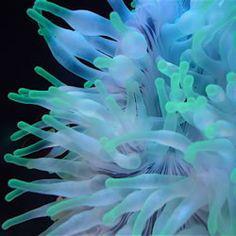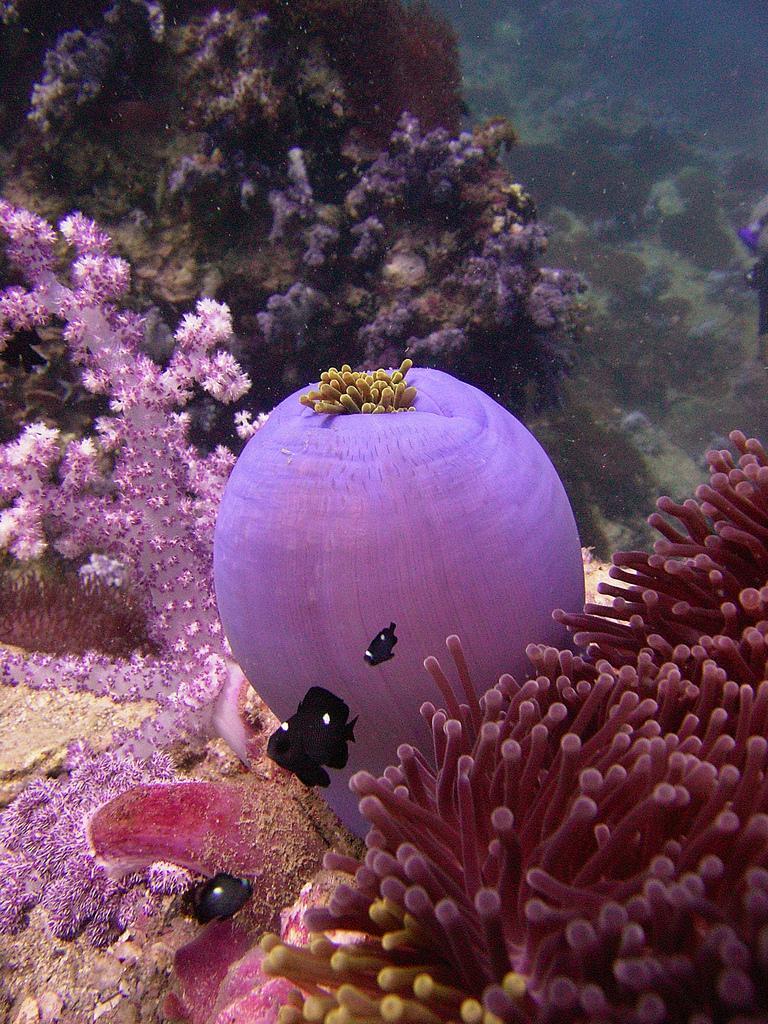The first image is the image on the left, the second image is the image on the right. For the images shown, is this caption "One of the anemones is spherical in shape." true? Answer yes or no. Yes. The first image is the image on the left, the second image is the image on the right. Considering the images on both sides, is "One image shows anemone tendrils sprouting from the top of a large round shape, with at least one fish swimming near it." valid? Answer yes or no. Yes. 